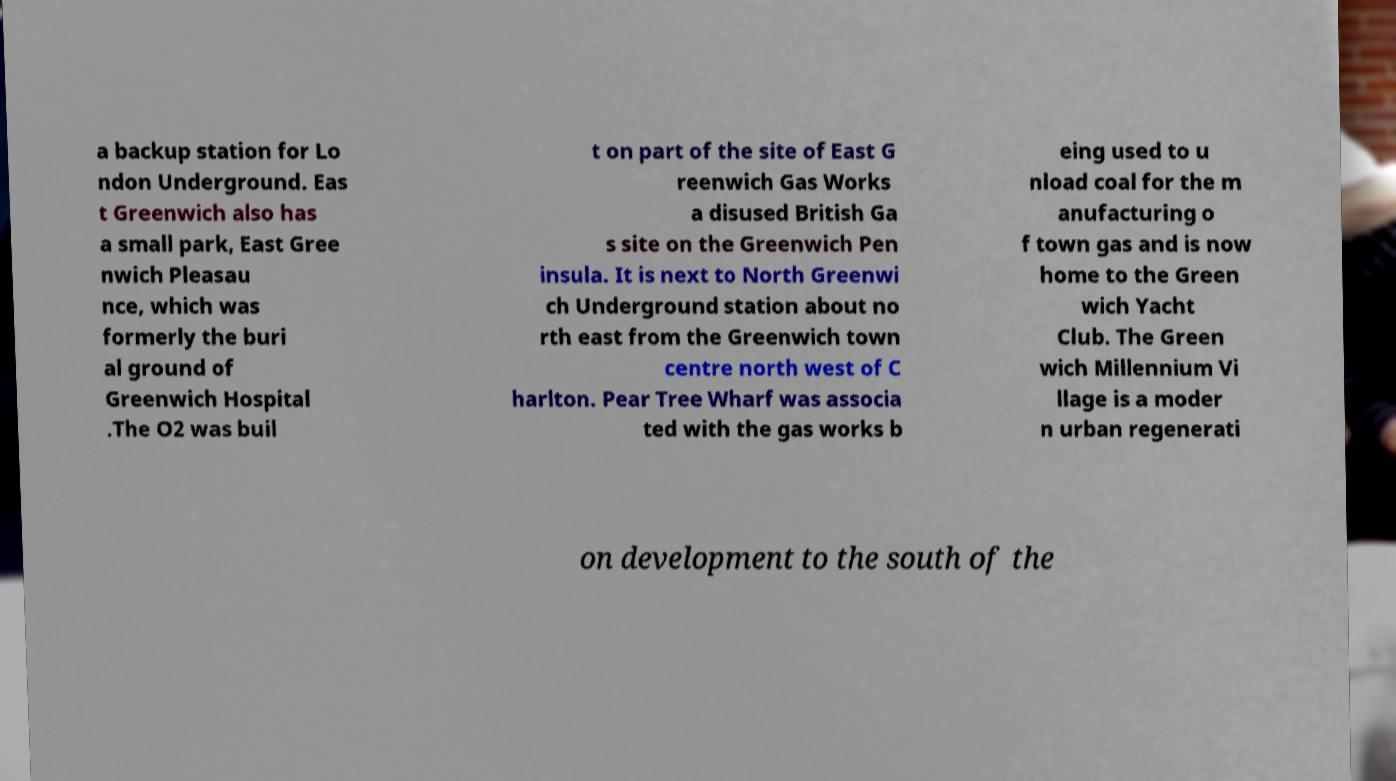For documentation purposes, I need the text within this image transcribed. Could you provide that? a backup station for Lo ndon Underground. Eas t Greenwich also has a small park, East Gree nwich Pleasau nce, which was formerly the buri al ground of Greenwich Hospital .The O2 was buil t on part of the site of East G reenwich Gas Works a disused British Ga s site on the Greenwich Pen insula. It is next to North Greenwi ch Underground station about no rth east from the Greenwich town centre north west of C harlton. Pear Tree Wharf was associa ted with the gas works b eing used to u nload coal for the m anufacturing o f town gas and is now home to the Green wich Yacht Club. The Green wich Millennium Vi llage is a moder n urban regenerati on development to the south of the 